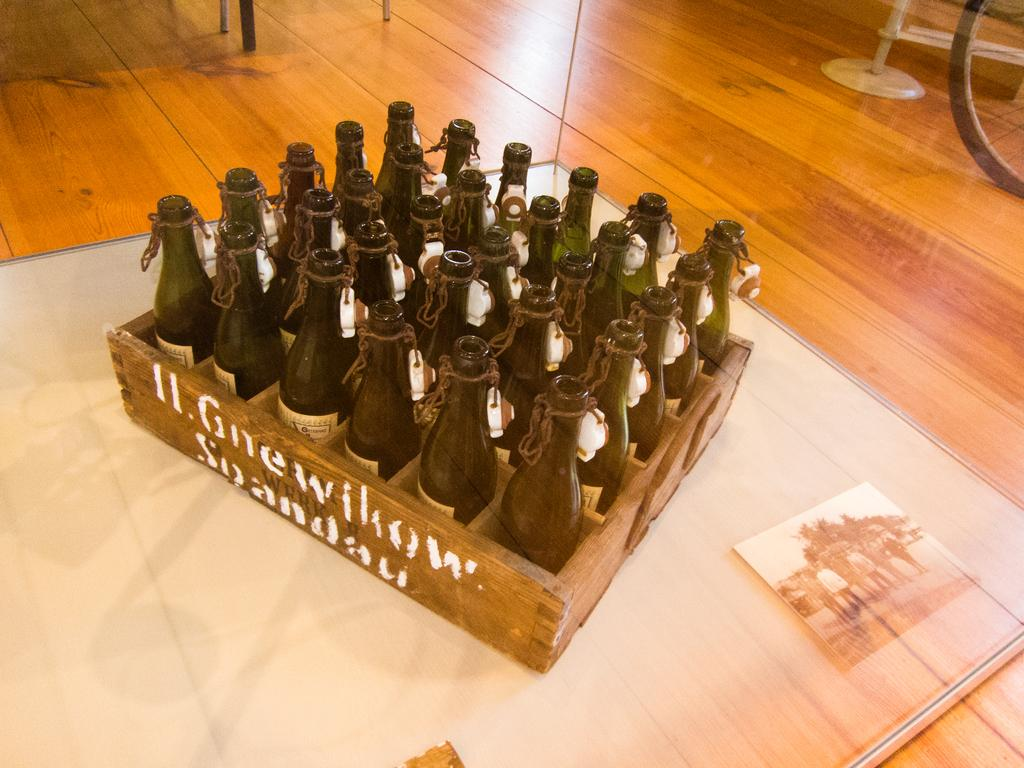<image>
Summarize the visual content of the image. A wooden box labeled Spandau carries a large number of empty glass bottles. 